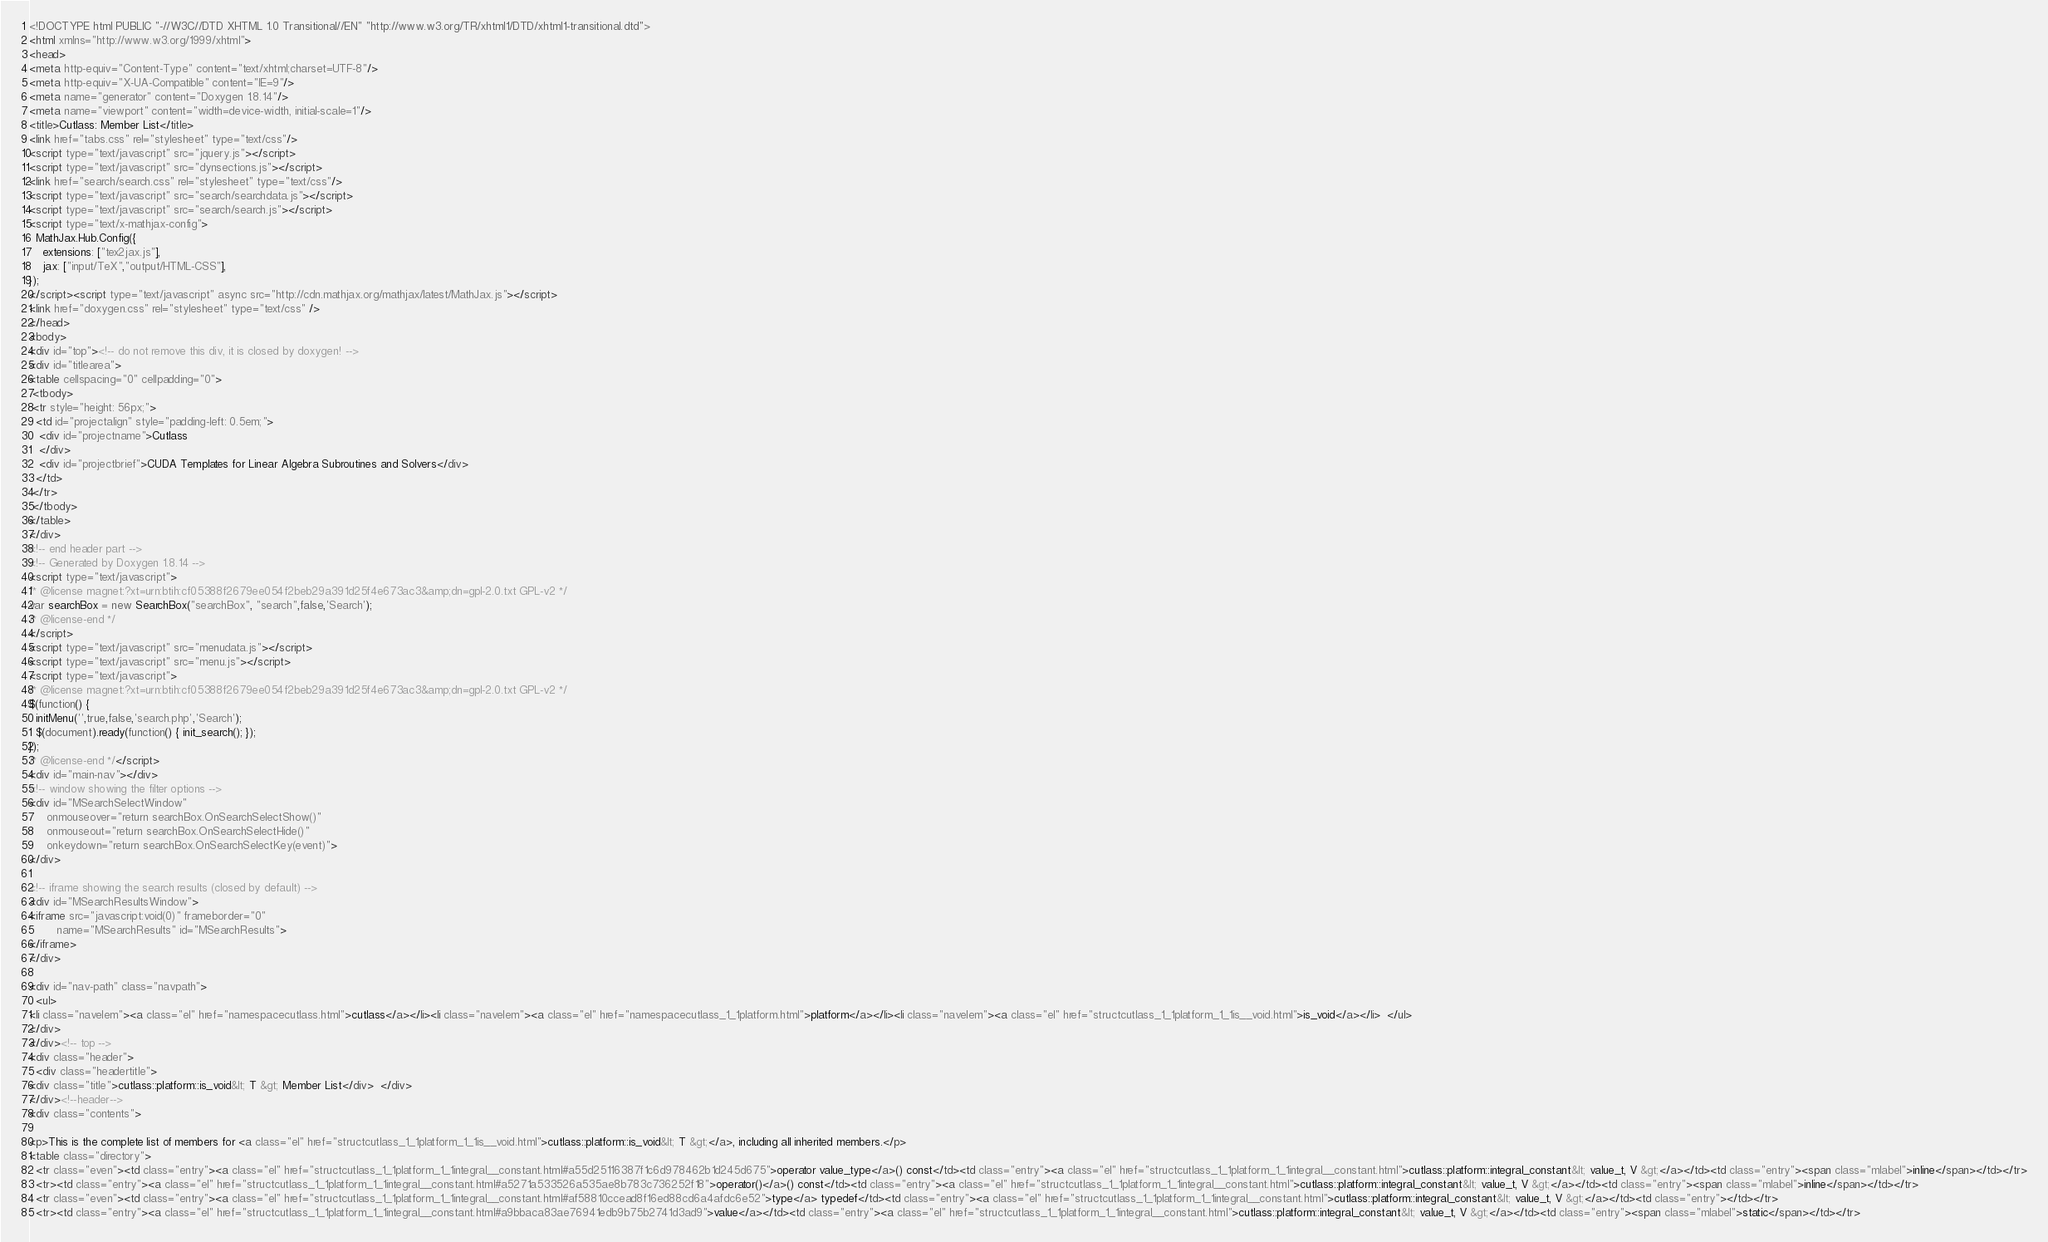Convert code to text. <code><loc_0><loc_0><loc_500><loc_500><_HTML_><!DOCTYPE html PUBLIC "-//W3C//DTD XHTML 1.0 Transitional//EN" "http://www.w3.org/TR/xhtml1/DTD/xhtml1-transitional.dtd">
<html xmlns="http://www.w3.org/1999/xhtml">
<head>
<meta http-equiv="Content-Type" content="text/xhtml;charset=UTF-8"/>
<meta http-equiv="X-UA-Compatible" content="IE=9"/>
<meta name="generator" content="Doxygen 1.8.14"/>
<meta name="viewport" content="width=device-width, initial-scale=1"/>
<title>Cutlass: Member List</title>
<link href="tabs.css" rel="stylesheet" type="text/css"/>
<script type="text/javascript" src="jquery.js"></script>
<script type="text/javascript" src="dynsections.js"></script>
<link href="search/search.css" rel="stylesheet" type="text/css"/>
<script type="text/javascript" src="search/searchdata.js"></script>
<script type="text/javascript" src="search/search.js"></script>
<script type="text/x-mathjax-config">
  MathJax.Hub.Config({
    extensions: ["tex2jax.js"],
    jax: ["input/TeX","output/HTML-CSS"],
});
</script><script type="text/javascript" async src="http://cdn.mathjax.org/mathjax/latest/MathJax.js"></script>
<link href="doxygen.css" rel="stylesheet" type="text/css" />
</head>
<body>
<div id="top"><!-- do not remove this div, it is closed by doxygen! -->
<div id="titlearea">
<table cellspacing="0" cellpadding="0">
 <tbody>
 <tr style="height: 56px;">
  <td id="projectalign" style="padding-left: 0.5em;">
   <div id="projectname">Cutlass
   </div>
   <div id="projectbrief">CUDA Templates for Linear Algebra Subroutines and Solvers</div>
  </td>
 </tr>
 </tbody>
</table>
</div>
<!-- end header part -->
<!-- Generated by Doxygen 1.8.14 -->
<script type="text/javascript">
/* @license magnet:?xt=urn:btih:cf05388f2679ee054f2beb29a391d25f4e673ac3&amp;dn=gpl-2.0.txt GPL-v2 */
var searchBox = new SearchBox("searchBox", "search",false,'Search');
/* @license-end */
</script>
<script type="text/javascript" src="menudata.js"></script>
<script type="text/javascript" src="menu.js"></script>
<script type="text/javascript">
/* @license magnet:?xt=urn:btih:cf05388f2679ee054f2beb29a391d25f4e673ac3&amp;dn=gpl-2.0.txt GPL-v2 */
$(function() {
  initMenu('',true,false,'search.php','Search');
  $(document).ready(function() { init_search(); });
});
/* @license-end */</script>
<div id="main-nav"></div>
<!-- window showing the filter options -->
<div id="MSearchSelectWindow"
     onmouseover="return searchBox.OnSearchSelectShow()"
     onmouseout="return searchBox.OnSearchSelectHide()"
     onkeydown="return searchBox.OnSearchSelectKey(event)">
</div>

<!-- iframe showing the search results (closed by default) -->
<div id="MSearchResultsWindow">
<iframe src="javascript:void(0)" frameborder="0" 
        name="MSearchResults" id="MSearchResults">
</iframe>
</div>

<div id="nav-path" class="navpath">
  <ul>
<li class="navelem"><a class="el" href="namespacecutlass.html">cutlass</a></li><li class="navelem"><a class="el" href="namespacecutlass_1_1platform.html">platform</a></li><li class="navelem"><a class="el" href="structcutlass_1_1platform_1_1is__void.html">is_void</a></li>  </ul>
</div>
</div><!-- top -->
<div class="header">
  <div class="headertitle">
<div class="title">cutlass::platform::is_void&lt; T &gt; Member List</div>  </div>
</div><!--header-->
<div class="contents">

<p>This is the complete list of members for <a class="el" href="structcutlass_1_1platform_1_1is__void.html">cutlass::platform::is_void&lt; T &gt;</a>, including all inherited members.</p>
<table class="directory">
  <tr class="even"><td class="entry"><a class="el" href="structcutlass_1_1platform_1_1integral__constant.html#a55d25116387f1c6d978462b1d245d675">operator value_type</a>() const</td><td class="entry"><a class="el" href="structcutlass_1_1platform_1_1integral__constant.html">cutlass::platform::integral_constant&lt; value_t, V &gt;</a></td><td class="entry"><span class="mlabel">inline</span></td></tr>
  <tr><td class="entry"><a class="el" href="structcutlass_1_1platform_1_1integral__constant.html#a5271a533526a535ae8b783c736252f18">operator()</a>() const</td><td class="entry"><a class="el" href="structcutlass_1_1platform_1_1integral__constant.html">cutlass::platform::integral_constant&lt; value_t, V &gt;</a></td><td class="entry"><span class="mlabel">inline</span></td></tr>
  <tr class="even"><td class="entry"><a class="el" href="structcutlass_1_1platform_1_1integral__constant.html#af58810ccead8f16ed88cd6a4afdc6e52">type</a> typedef</td><td class="entry"><a class="el" href="structcutlass_1_1platform_1_1integral__constant.html">cutlass::platform::integral_constant&lt; value_t, V &gt;</a></td><td class="entry"></td></tr>
  <tr><td class="entry"><a class="el" href="structcutlass_1_1platform_1_1integral__constant.html#a9bbaca83ae76941edb9b75b2741d3ad9">value</a></td><td class="entry"><a class="el" href="structcutlass_1_1platform_1_1integral__constant.html">cutlass::platform::integral_constant&lt; value_t, V &gt;</a></td><td class="entry"><span class="mlabel">static</span></td></tr></code> 